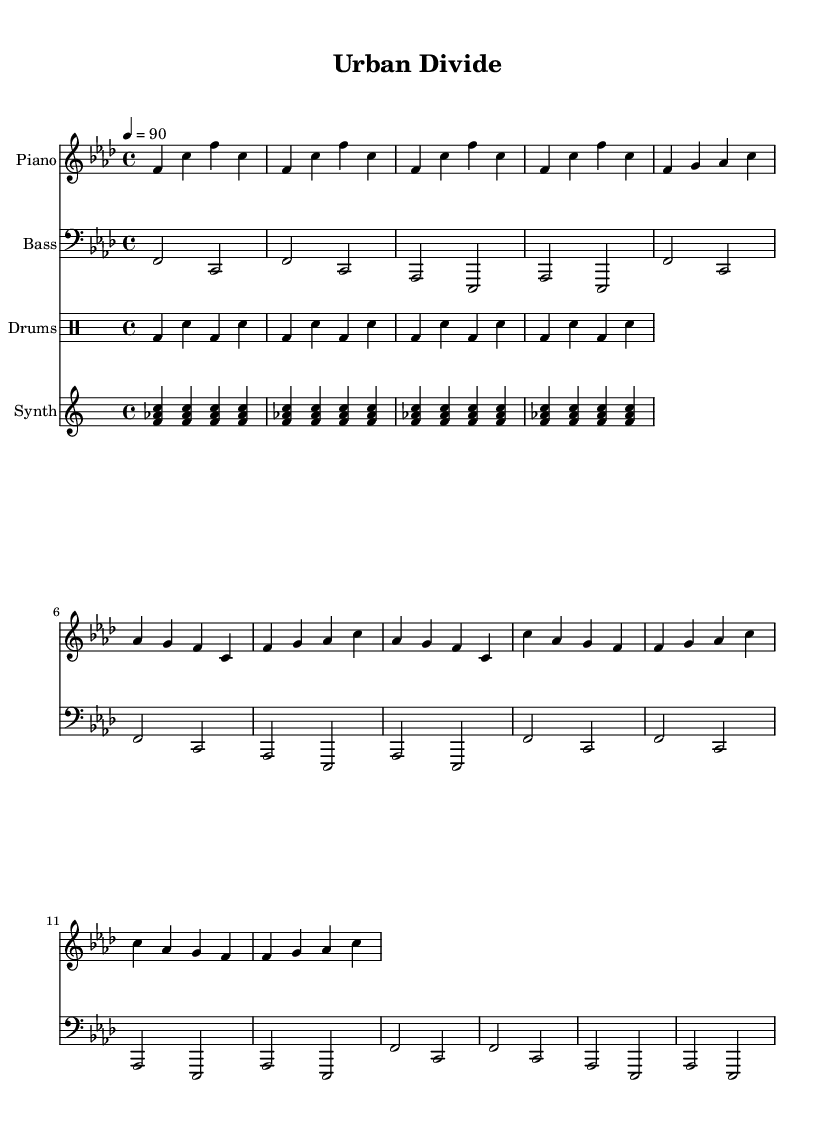What is the key signature of this music? The key signature is F minor, which has four flats indicated by the presence of the flat sign on the B, E, A, and D notes in the staff.
Answer: F minor What is the time signature of this music? The time signature is 4/4, represented by the notation that indicates four beats in a measure, with each quarter note receiving one beat.
Answer: 4/4 What is the tempo of this music? The tempo is marked at 90 beats per minute, shown in the score where it specifies the speed of the piece.
Answer: 90 How many measures are in the verse shown? The verse shown consists of 4 measures as indicated by the distinct grouping of notes divided by vertical lines in the staff.
Answer: 4 Identify the instrument playing the bass line. The instrument playing the bass line is specified as "Bass" in the staff heading, showing that this staff is dedicated to the bass instrument.
Answer: Bass What is the repeated rhythmic pattern in the drum part? The repeated rhythmic pattern in the drum part consists of a bass drum followed by a snare drum, repeating four times, indicated by the notation in the drum staff.
Answer: BD SN How many times is the synth pattern repeated? The synth pattern is repeated four times, demonstrated by the repeat signs showing how many times the sequence appears in the score.
Answer: 4 